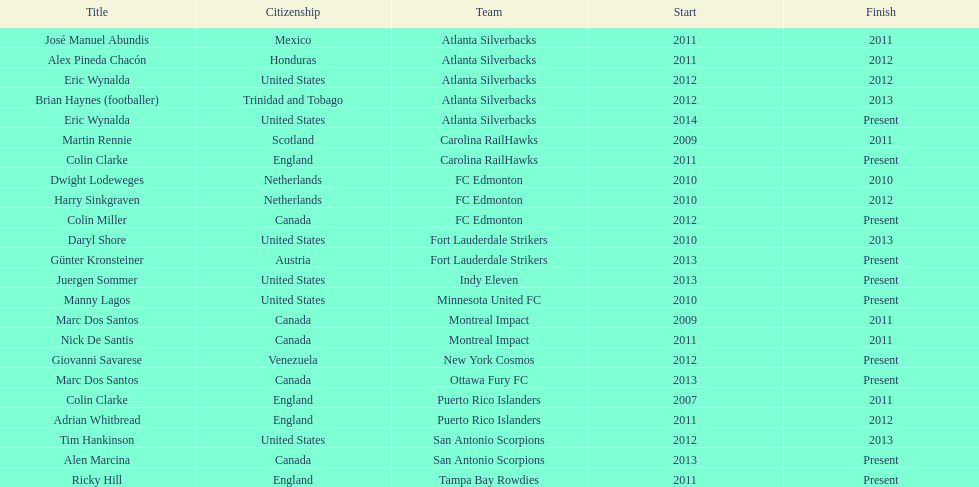How many total coaches on the list are from canada? 5. 